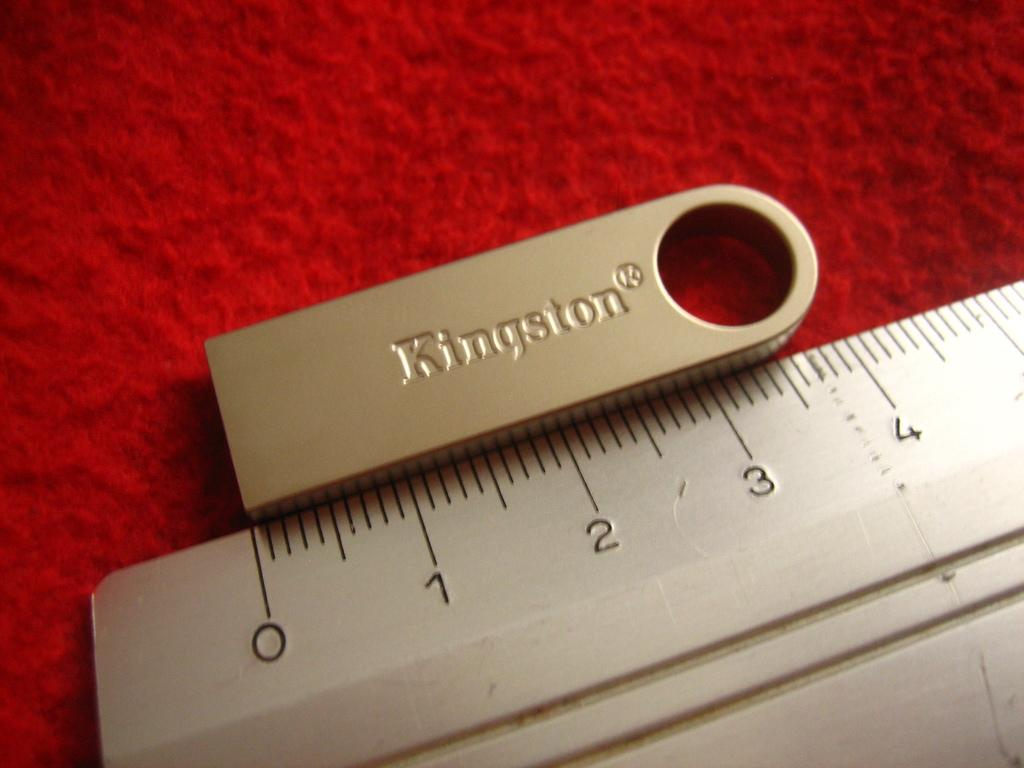<image>
Render a clear and concise summary of the photo. A Kingston Flash Drive sits next to a ruler which measures it as about four inches long. 